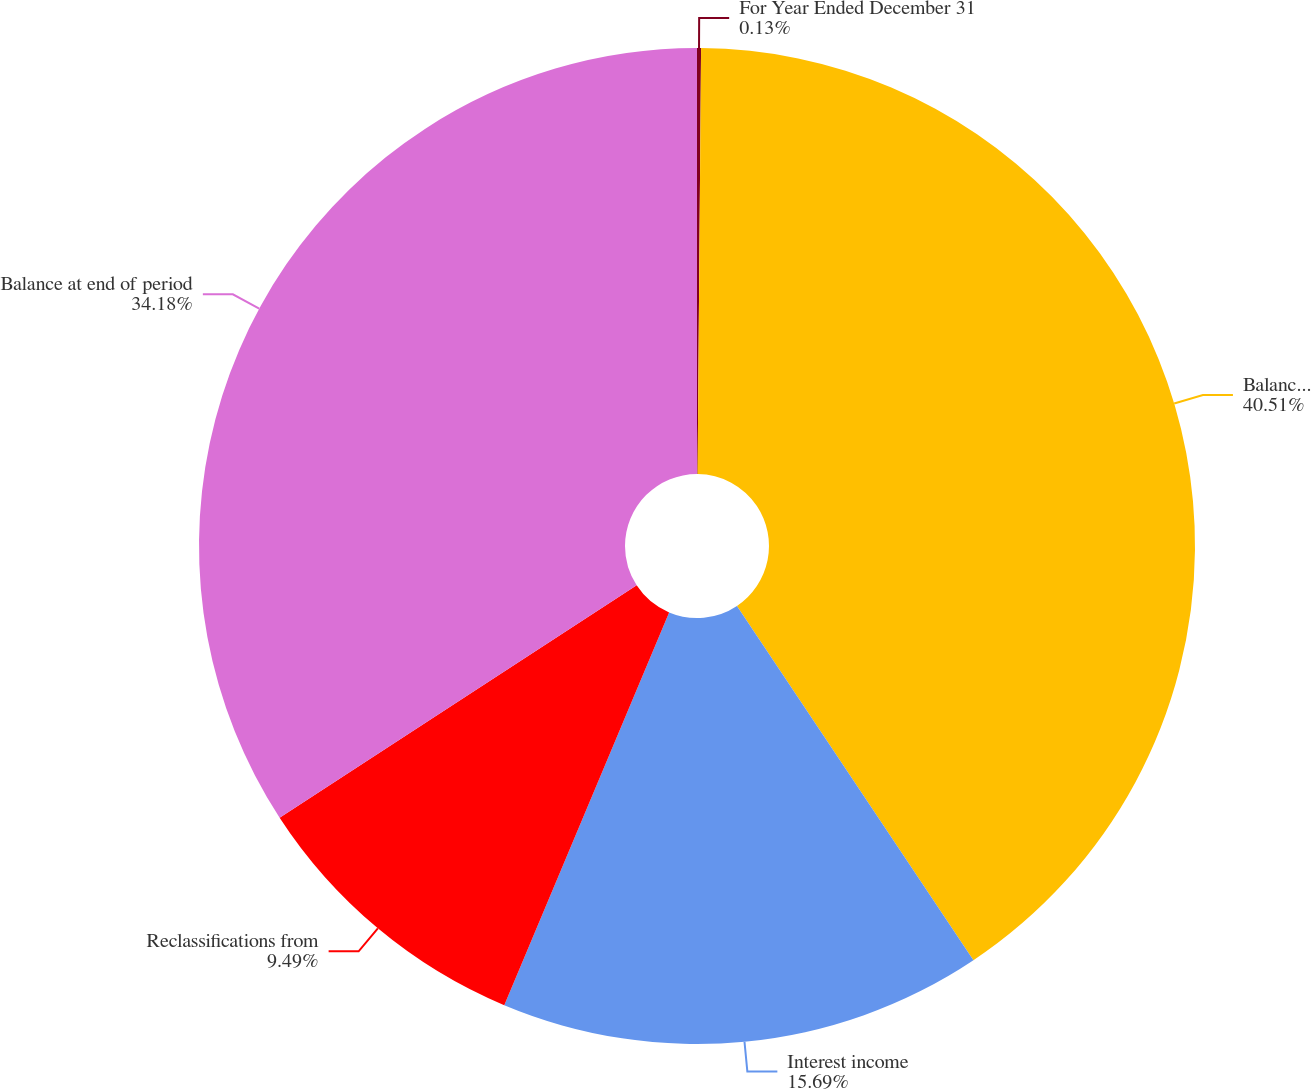Convert chart to OTSL. <chart><loc_0><loc_0><loc_500><loc_500><pie_chart><fcel>For Year Ended December 31<fcel>Balance at beginning of period<fcel>Interest income<fcel>Reclassifications from<fcel>Balance at end of period<nl><fcel>0.13%<fcel>40.5%<fcel>15.69%<fcel>9.49%<fcel>34.18%<nl></chart> 